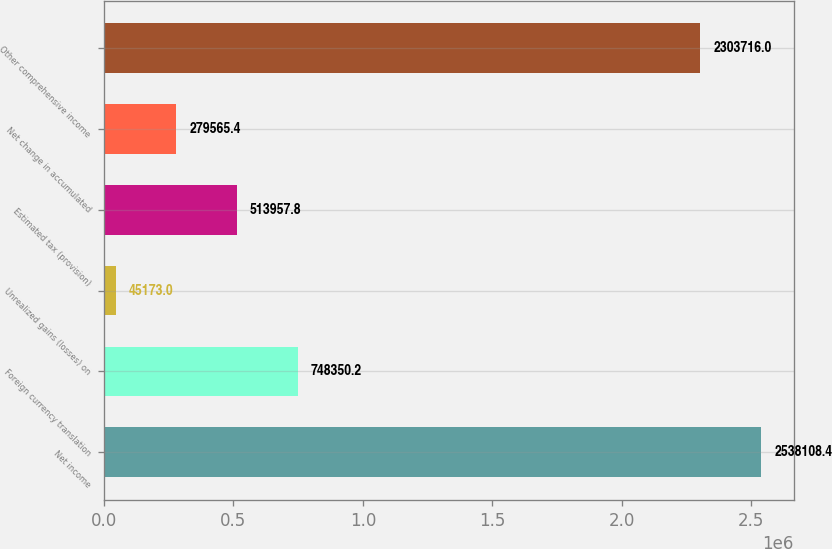<chart> <loc_0><loc_0><loc_500><loc_500><bar_chart><fcel>Net income<fcel>Foreign currency translation<fcel>Unrealized gains (losses) on<fcel>Estimated tax (provision)<fcel>Net change in accumulated<fcel>Other comprehensive income<nl><fcel>2.53811e+06<fcel>748350<fcel>45173<fcel>513958<fcel>279565<fcel>2.30372e+06<nl></chart> 